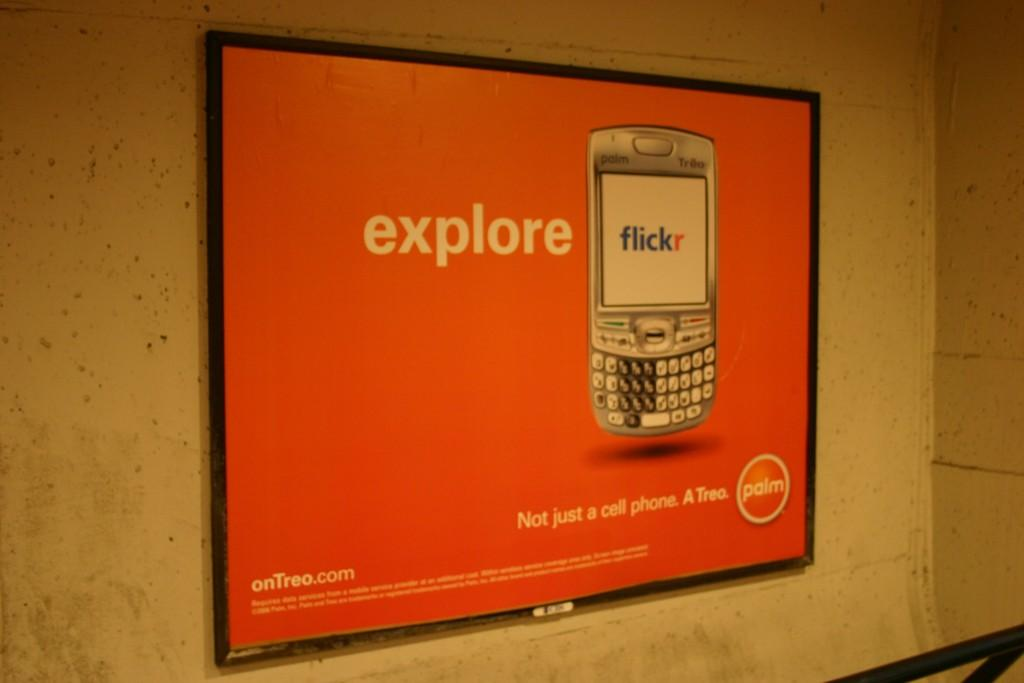What type of structure can be seen in the image? There is a wall in the image. What is attached to the wall in the image? There is a board with an image and text in the image. Can you describe the object in the bottom right corner of the image? Unfortunately, the facts provided do not give enough information to describe the object in the bottom right corner of the image. How many flames can be seen on the sugar in the image? There is no sugar or flame present in the image. What type of baseball game is being played in the image? There is no baseball game present in the image. 